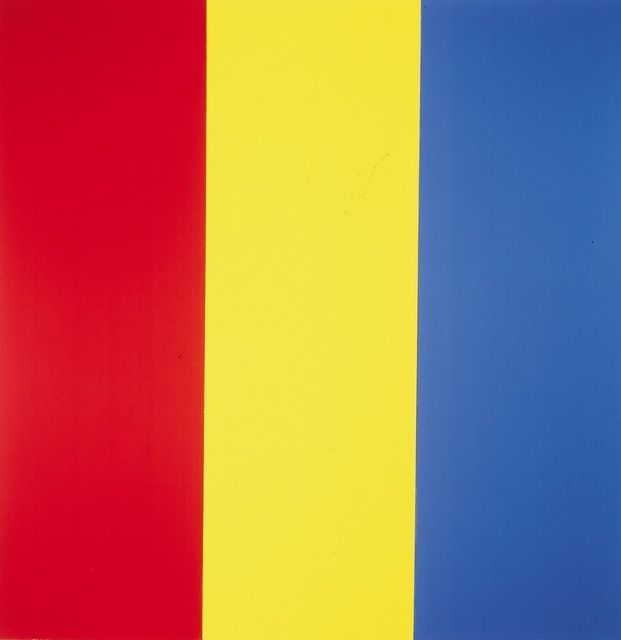Imagine the colors could speak, what conversation might they be having? Red: 'I represent the fire and heart of life. Without me, where would be the drive and determination to press forward?'
Yellow: 'Indeed, Red, but it is I who bring joy and illuminate the path. My brightness lifts spirits and spreads warmth that is vital for growth.'
Blue: 'Both of you hold key parts in the tapestry of existence. My presence brings the calm and introspection necessary to navigate life’s turbulent seas. Together, we embody the balance that life needs.'
Red: 'True, each of us brings something essential to the palette of life. Our unity makes the world vibrant and whole.'
Yellow: 'Let’s continue to blend harmoniously, for our combined light and energy create the masterpiece that is life.'
Blue: 'Agreed, united we form the essence of existence, a perfect harmony of emotions.' 